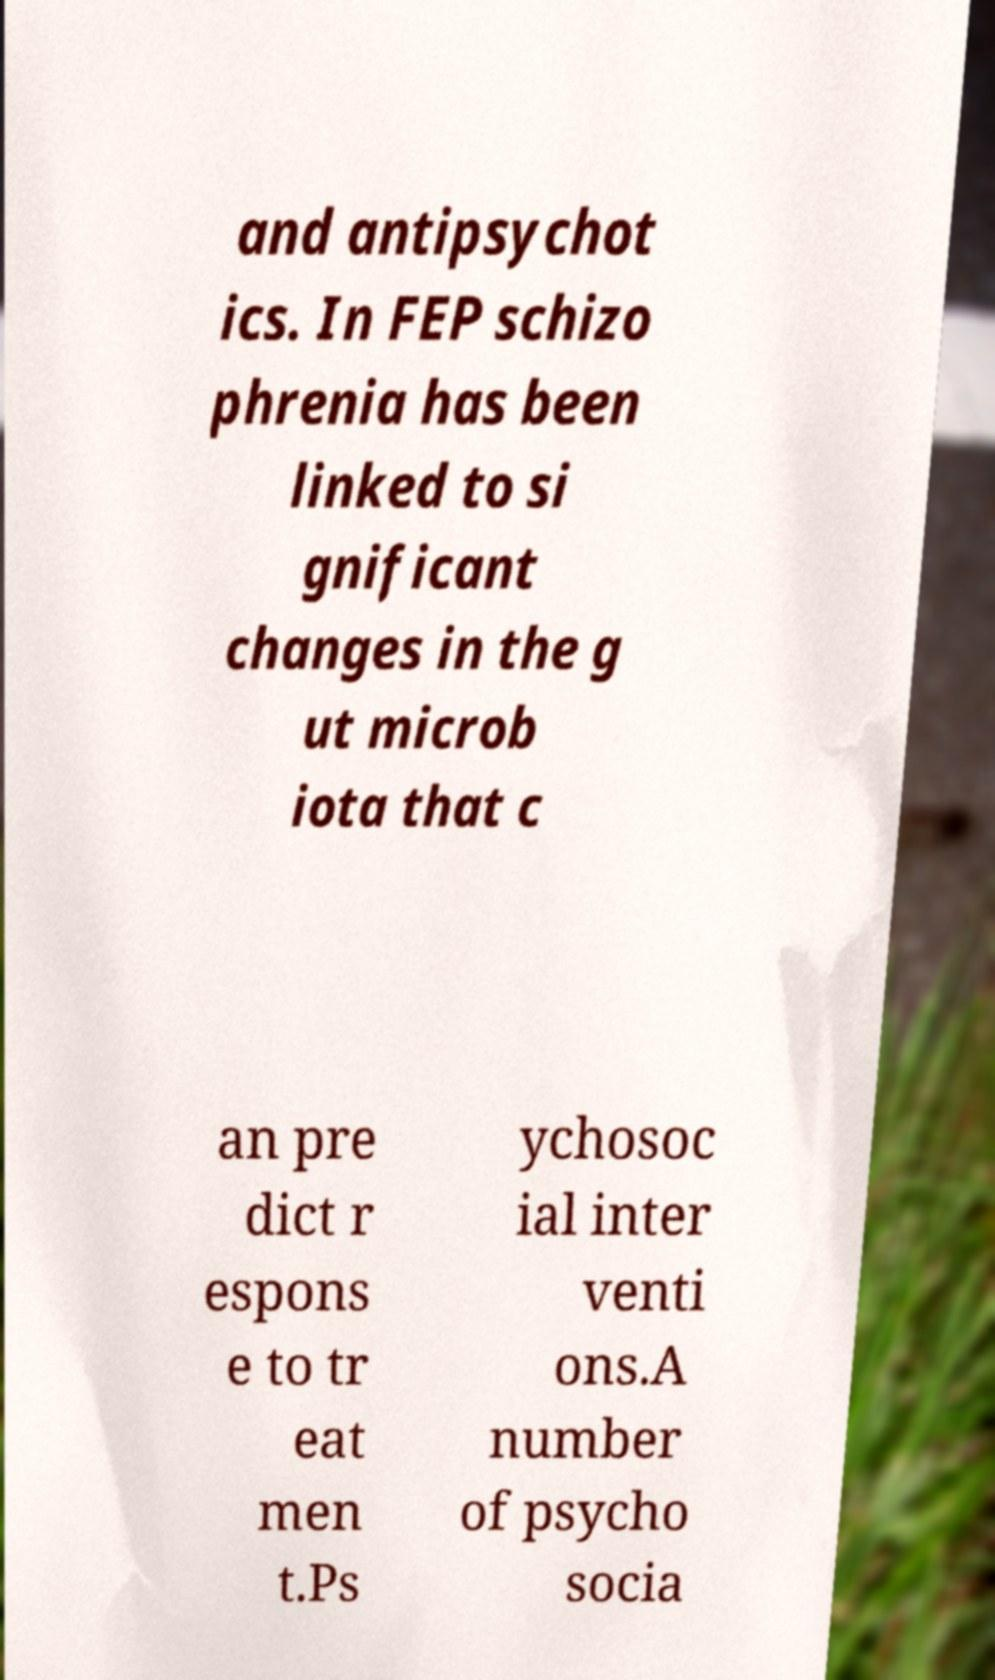Can you accurately transcribe the text from the provided image for me? and antipsychot ics. In FEP schizo phrenia has been linked to si gnificant changes in the g ut microb iota that c an pre dict r espons e to tr eat men t.Ps ychosoc ial inter venti ons.A number of psycho socia 